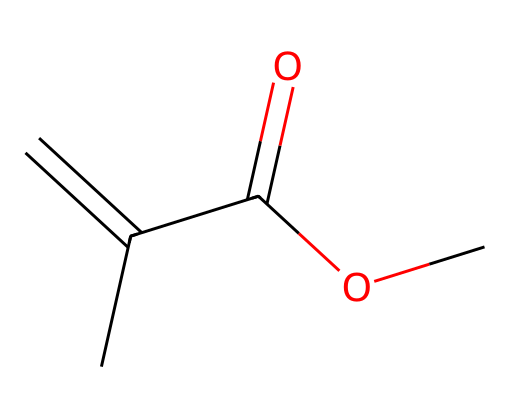What is the molecular formula of methyl methacrylate? To determine the molecular formula, count the carbon (C), hydrogen (H), and oxygen (O) atoms present in the structure based on the SMILES. There are 5 carbon atoms, 8 hydrogen atoms, and 2 oxygen atoms, leading to the formula C5H8O2.
Answer: C5H8O2 How many double bonds does methyl methacrylate have? Visualizing the structure from the SMILES representation, one double bond is evident between the first two carbon atoms (C=C). Thus, it contains one double bond.
Answer: 1 What functional groups are present in methyl methacrylate? By inspecting the structure, methyl methacrylate features a methacrylate group (the carbon double-bonded to another carbon) and an ester group, identifiable by the C(=O)O segment. Therefore, the functional groups are an alkene and an ester.
Answer: alkene and ester What type of polymer does methyl methacrylate commonly form? Methyl methacrylate is primarily used to create poly(methyl methacrylate) or PMMA when polymerized. This chemical is a common thermoplastic used for acrylic glass.
Answer: PMMA Is methyl methacrylate polar or nonpolar? To assess the polarity, review the chemical structure for the presence of polar bonds, specifically the C=O bond within the ester group, which contributes to the overall polarity. However, due to its overall hydrocarbon nature, it is considered nonpolar.
Answer: nonpolar What is the significance of the carbon-carbon double bond in methyl methacrylate? The carbon-carbon double bond increases the reactivity of the molecule, allowing it to undergo polymerization, which is crucial for forming PMMA and related materials. This synthetic process is initiated by the double bond, thus playing a critical role in the polymerization.
Answer: polymerization 